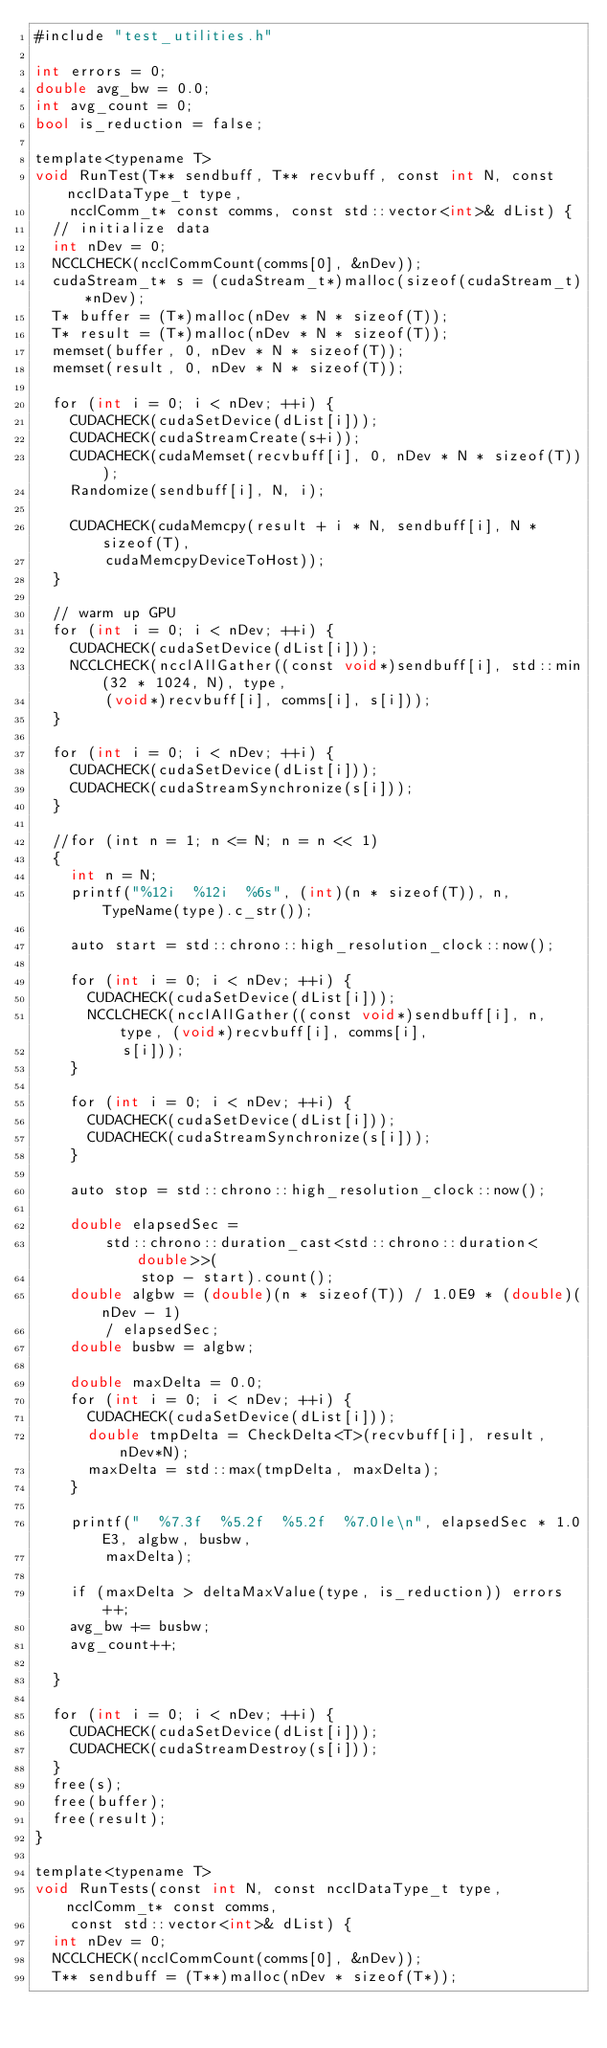Convert code to text. <code><loc_0><loc_0><loc_500><loc_500><_Cuda_>#include "test_utilities.h"

int errors = 0;
double avg_bw = 0.0;
int avg_count = 0;
bool is_reduction = false;

template<typename T>
void RunTest(T** sendbuff, T** recvbuff, const int N, const ncclDataType_t type,
    ncclComm_t* const comms, const std::vector<int>& dList) {
  // initialize data
  int nDev = 0;
  NCCLCHECK(ncclCommCount(comms[0], &nDev));
  cudaStream_t* s = (cudaStream_t*)malloc(sizeof(cudaStream_t)*nDev);
  T* buffer = (T*)malloc(nDev * N * sizeof(T));
  T* result = (T*)malloc(nDev * N * sizeof(T));
  memset(buffer, 0, nDev * N * sizeof(T));
  memset(result, 0, nDev * N * sizeof(T));

  for (int i = 0; i < nDev; ++i) {
    CUDACHECK(cudaSetDevice(dList[i]));
    CUDACHECK(cudaStreamCreate(s+i));
    CUDACHECK(cudaMemset(recvbuff[i], 0, nDev * N * sizeof(T)));
    Randomize(sendbuff[i], N, i);

    CUDACHECK(cudaMemcpy(result + i * N, sendbuff[i], N * sizeof(T),
        cudaMemcpyDeviceToHost));
  }

  // warm up GPU
  for (int i = 0; i < nDev; ++i) {
    CUDACHECK(cudaSetDevice(dList[i]));
    NCCLCHECK(ncclAllGather((const void*)sendbuff[i], std::min(32 * 1024, N), type,
        (void*)recvbuff[i], comms[i], s[i]));
  }

  for (int i = 0; i < nDev; ++i) {
    CUDACHECK(cudaSetDevice(dList[i]));
    CUDACHECK(cudaStreamSynchronize(s[i]));
  }

  //for (int n = 1; n <= N; n = n << 1)
  {
    int n = N;
    printf("%12i  %12i  %6s", (int)(n * sizeof(T)), n, TypeName(type).c_str());

    auto start = std::chrono::high_resolution_clock::now();

    for (int i = 0; i < nDev; ++i) {
      CUDACHECK(cudaSetDevice(dList[i]));
      NCCLCHECK(ncclAllGather((const void*)sendbuff[i], n, type, (void*)recvbuff[i], comms[i],
          s[i]));
    }

    for (int i = 0; i < nDev; ++i) {
      CUDACHECK(cudaSetDevice(dList[i]));
      CUDACHECK(cudaStreamSynchronize(s[i]));
    }

    auto stop = std::chrono::high_resolution_clock::now();

    double elapsedSec =
        std::chrono::duration_cast<std::chrono::duration<double>>(
            stop - start).count();
    double algbw = (double)(n * sizeof(T)) / 1.0E9 * (double)(nDev - 1)
        / elapsedSec;
    double busbw = algbw;

    double maxDelta = 0.0;
    for (int i = 0; i < nDev; ++i) {
      CUDACHECK(cudaSetDevice(dList[i]));
      double tmpDelta = CheckDelta<T>(recvbuff[i], result, nDev*N);
      maxDelta = std::max(tmpDelta, maxDelta);
    }

    printf("  %7.3f  %5.2f  %5.2f  %7.0le\n", elapsedSec * 1.0E3, algbw, busbw,
        maxDelta);

    if (maxDelta > deltaMaxValue(type, is_reduction)) errors++;
    avg_bw += busbw;
    avg_count++;

  }

  for (int i = 0; i < nDev; ++i) {
    CUDACHECK(cudaSetDevice(dList[i]));
    CUDACHECK(cudaStreamDestroy(s[i]));
  }
  free(s);
  free(buffer);
  free(result);
}

template<typename T>
void RunTests(const int N, const ncclDataType_t type, ncclComm_t* const comms,
    const std::vector<int>& dList) {
  int nDev = 0;
  NCCLCHECK(ncclCommCount(comms[0], &nDev));
  T** sendbuff = (T**)malloc(nDev * sizeof(T*));</code> 